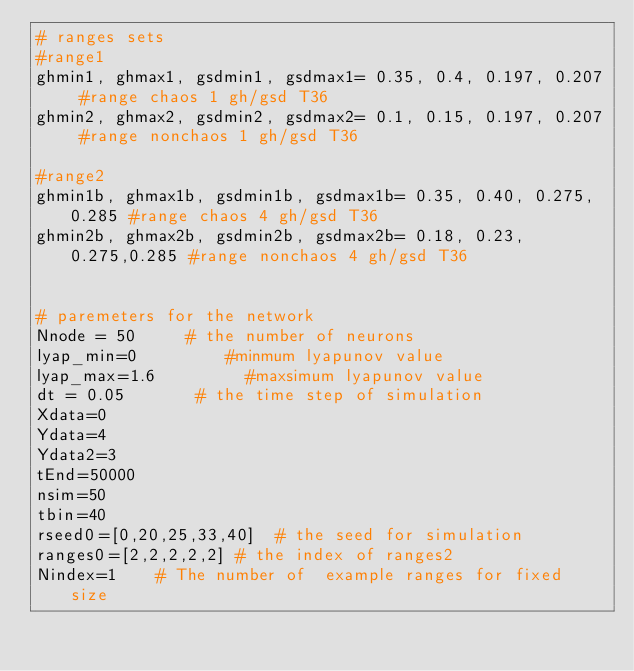<code> <loc_0><loc_0><loc_500><loc_500><_Python_># ranges sets 
#range1
ghmin1, ghmax1, gsdmin1, gsdmax1= 0.35, 0.4, 0.197, 0.207 #range chaos 1 gh/gsd T36
ghmin2, ghmax2, gsdmin2, gsdmax2= 0.1, 0.15, 0.197, 0.207 #range nonchaos 1 gh/gsd T36

#range2
ghmin1b, ghmax1b, gsdmin1b, gsdmax1b= 0.35, 0.40, 0.275, 0.285 #range chaos 4 gh/gsd T36
ghmin2b, ghmax2b, gsdmin2b, gsdmax2b= 0.18, 0.23, 0.275,0.285 #range nonchaos 4 gh/gsd T36


# paremeters for the network
Nnode = 50     # the number of neurons
lyap_min=0         #minmum lyapunov value
lyap_max=1.6         #maxsimum lyapunov value
dt = 0.05       # the time step of simulation
Xdata=0
Ydata=4
Ydata2=3
tEnd=50000
nsim=50
tbin=40
rseed0=[0,20,25,33,40]  # the seed for simulation
ranges0=[2,2,2,2,2] # the index of ranges2
Nindex=1    # The number of  example ranges for fixed size
</code> 